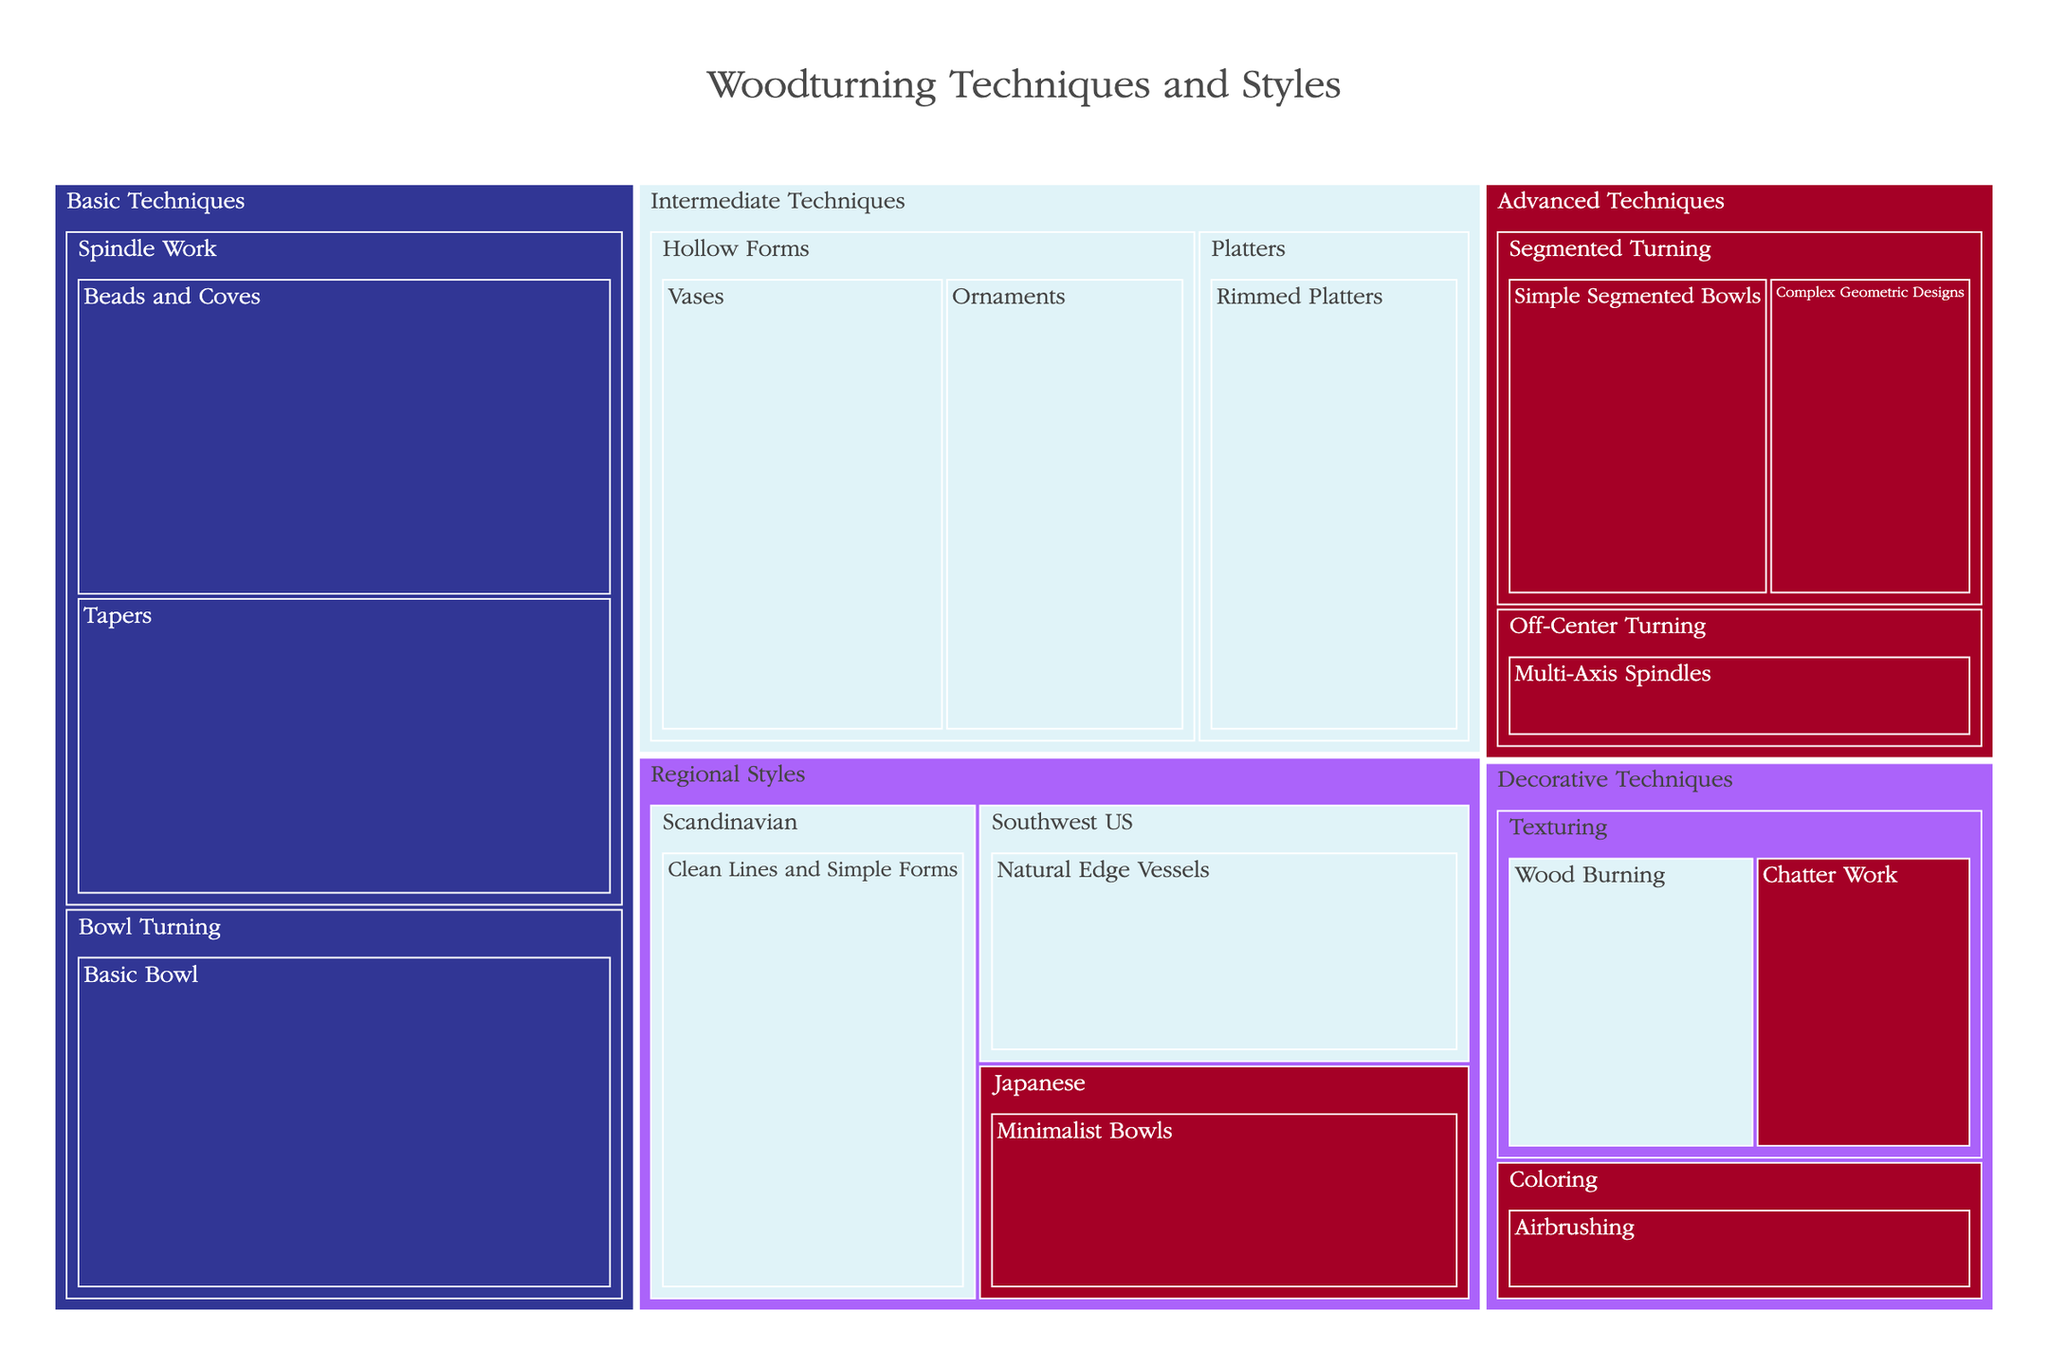what is the most popular technique for beginners? The treemap displays various techniques categorized by skill level. For beginners, we need to look at the 'Beads and Coves', 'Tapers', and 'Basic Bowl' techniques. From these, 'Basic Bowl' has the highest popularity at 90.
Answer: Basic Bowl which subcategory under intermediate techniques has the highest popularity? Within Intermediate Techniques, the subcategories are 'Hollow Forms' and 'Platters'. 'Hollow Forms' contains 'Vases' (65) and 'Ornaments' (55) while 'Platters' contains 'Rimmed Platters' (60). 'Hollow Forms' has a higher maximum popularity of 65.
Answer: Hollow Forms how popular is the Scandinavian regional style? In the Regional Styles category, Scandinavian corresponds to 'Clean Lines and Simple Forms' with a popularity of 70.
Answer: 70 which advanced technique has the lowest popularity? Under Advanced Techniques, the subcategories are 'Segmented Turning' and 'Off-Center Turning'. The techniques are 'Simple Segmented Bowls' (45), 'Complex Geometric Designs' (35), and 'Multi-Axis Spindles' (30). 'Multi-Axis Spindles' has the lowest popularity at 30.
Answer: Multi-Axis Spindles compare the popularity of 'Wood Burning' and 'Chatter Work' decorative techniques Both are under the 'Texturing' subcategory of Decorative Techniques. 'Wood Burning' has a popularity of 40, and 'Chatter Work' has 35. Therefore, 'Wood Burning' is more popular.
Answer: Wood Burning what is the average popularity of intermediate techniques? We sum the popularity of all intermediate techniques: 'Vases' (65), 'Ornaments' (55), 'Rimmed Platters' (60), 'Clean Lines and Simple Forms' (70), and 'Natural Edge Vessels' (55). The sum is 305. Divide by the number of techniques (5) to get the average: 305 / 5 = 61.
Answer: 61 which technique in the 'Japanese' regional style is classified as advanced? Within Regional Styles, specifically Japanese, the techniques listed are only 'Minimalist Bowls' and it is categorized as Advanced.
Answer: Minimalist Bowls how many techniques are categorized as Decorative Techniques? The treemap shows Decorative Techniques broken down into 'Texturing' and 'Coloring'. Under Texturing, there are two techniques: 'Wood Burning' and 'Chatter Work'. Under Coloring, there is one technique: 'Airbrushing'. Therefore, three techniques are categorized under Decorative Techniques.
Answer: 3 which beginner spindle work technique is more popular? The techniques under Beginner Spindle Work are 'Beads and Coves' (80) and 'Tapers' (75). 'Beads and Coves' is more popular.
Answer: Beads and Coves which advanced technique has the highest popularity? Advanced Techniques include 'Simple Segmented Bowls' (45), 'Complex Geometric Designs' (35), and 'Multi-Axis Spindles' (30). The highest popularity among these is 'Simple Segmented Bowls' with 45.
Answer: Simple Segmented Bowls 